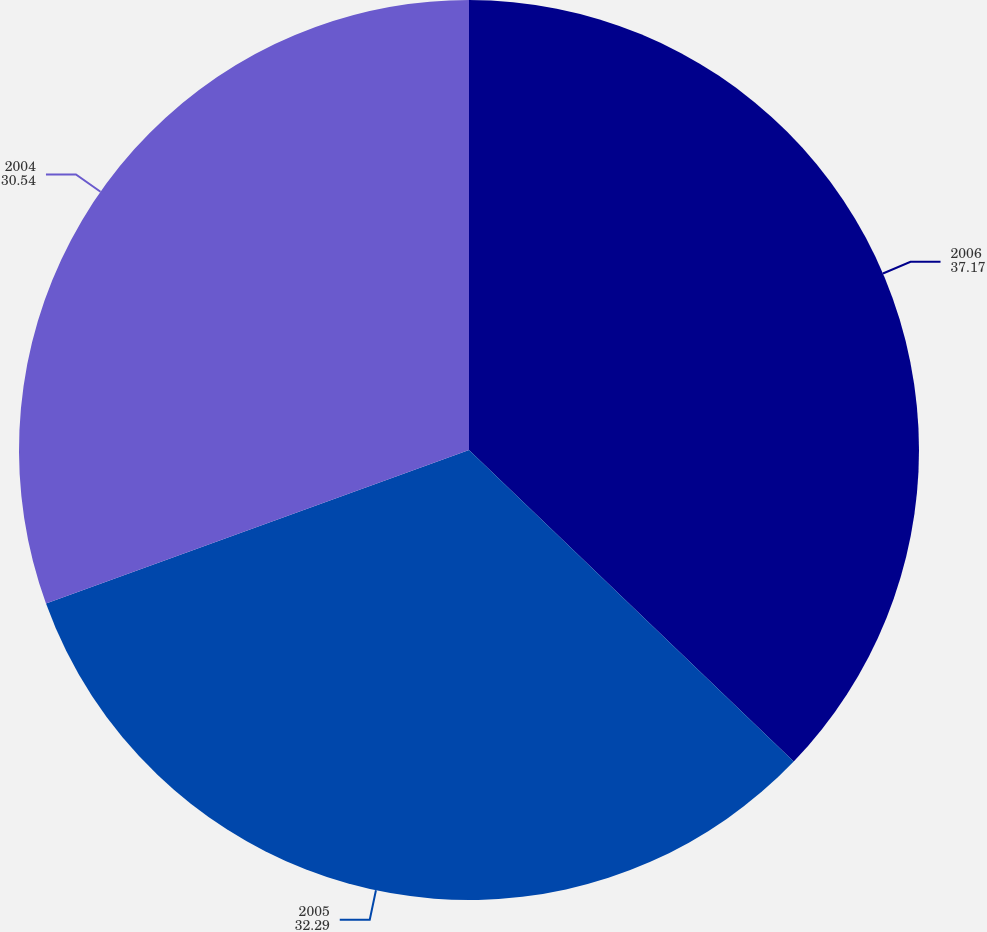<chart> <loc_0><loc_0><loc_500><loc_500><pie_chart><fcel>2006<fcel>2005<fcel>2004<nl><fcel>37.17%<fcel>32.29%<fcel>30.54%<nl></chart> 